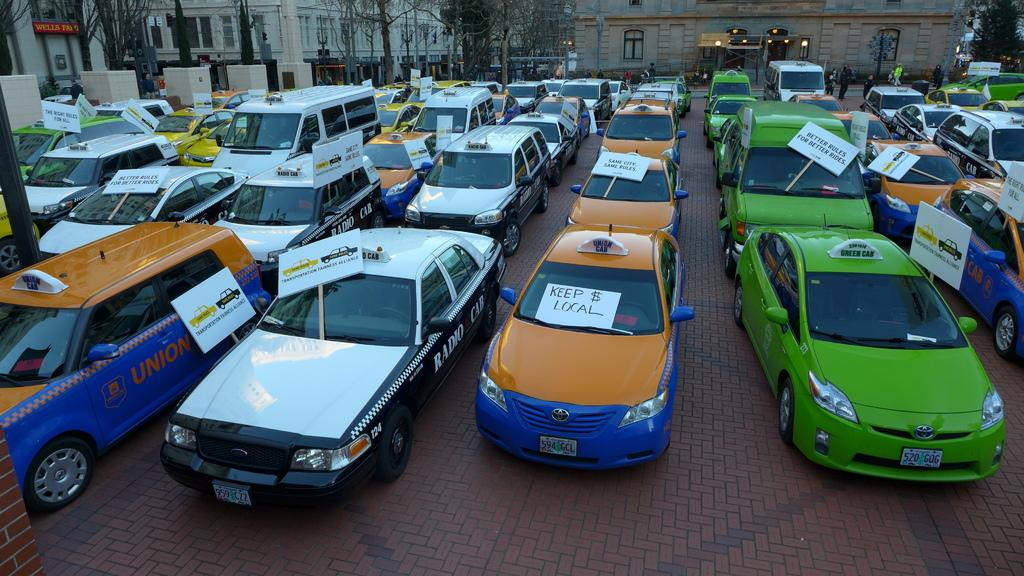Provide a one-sentence caption for the provided image. Multiple taxi cabs are parked in rows, all with signs on them, picketing for better cab fares. 